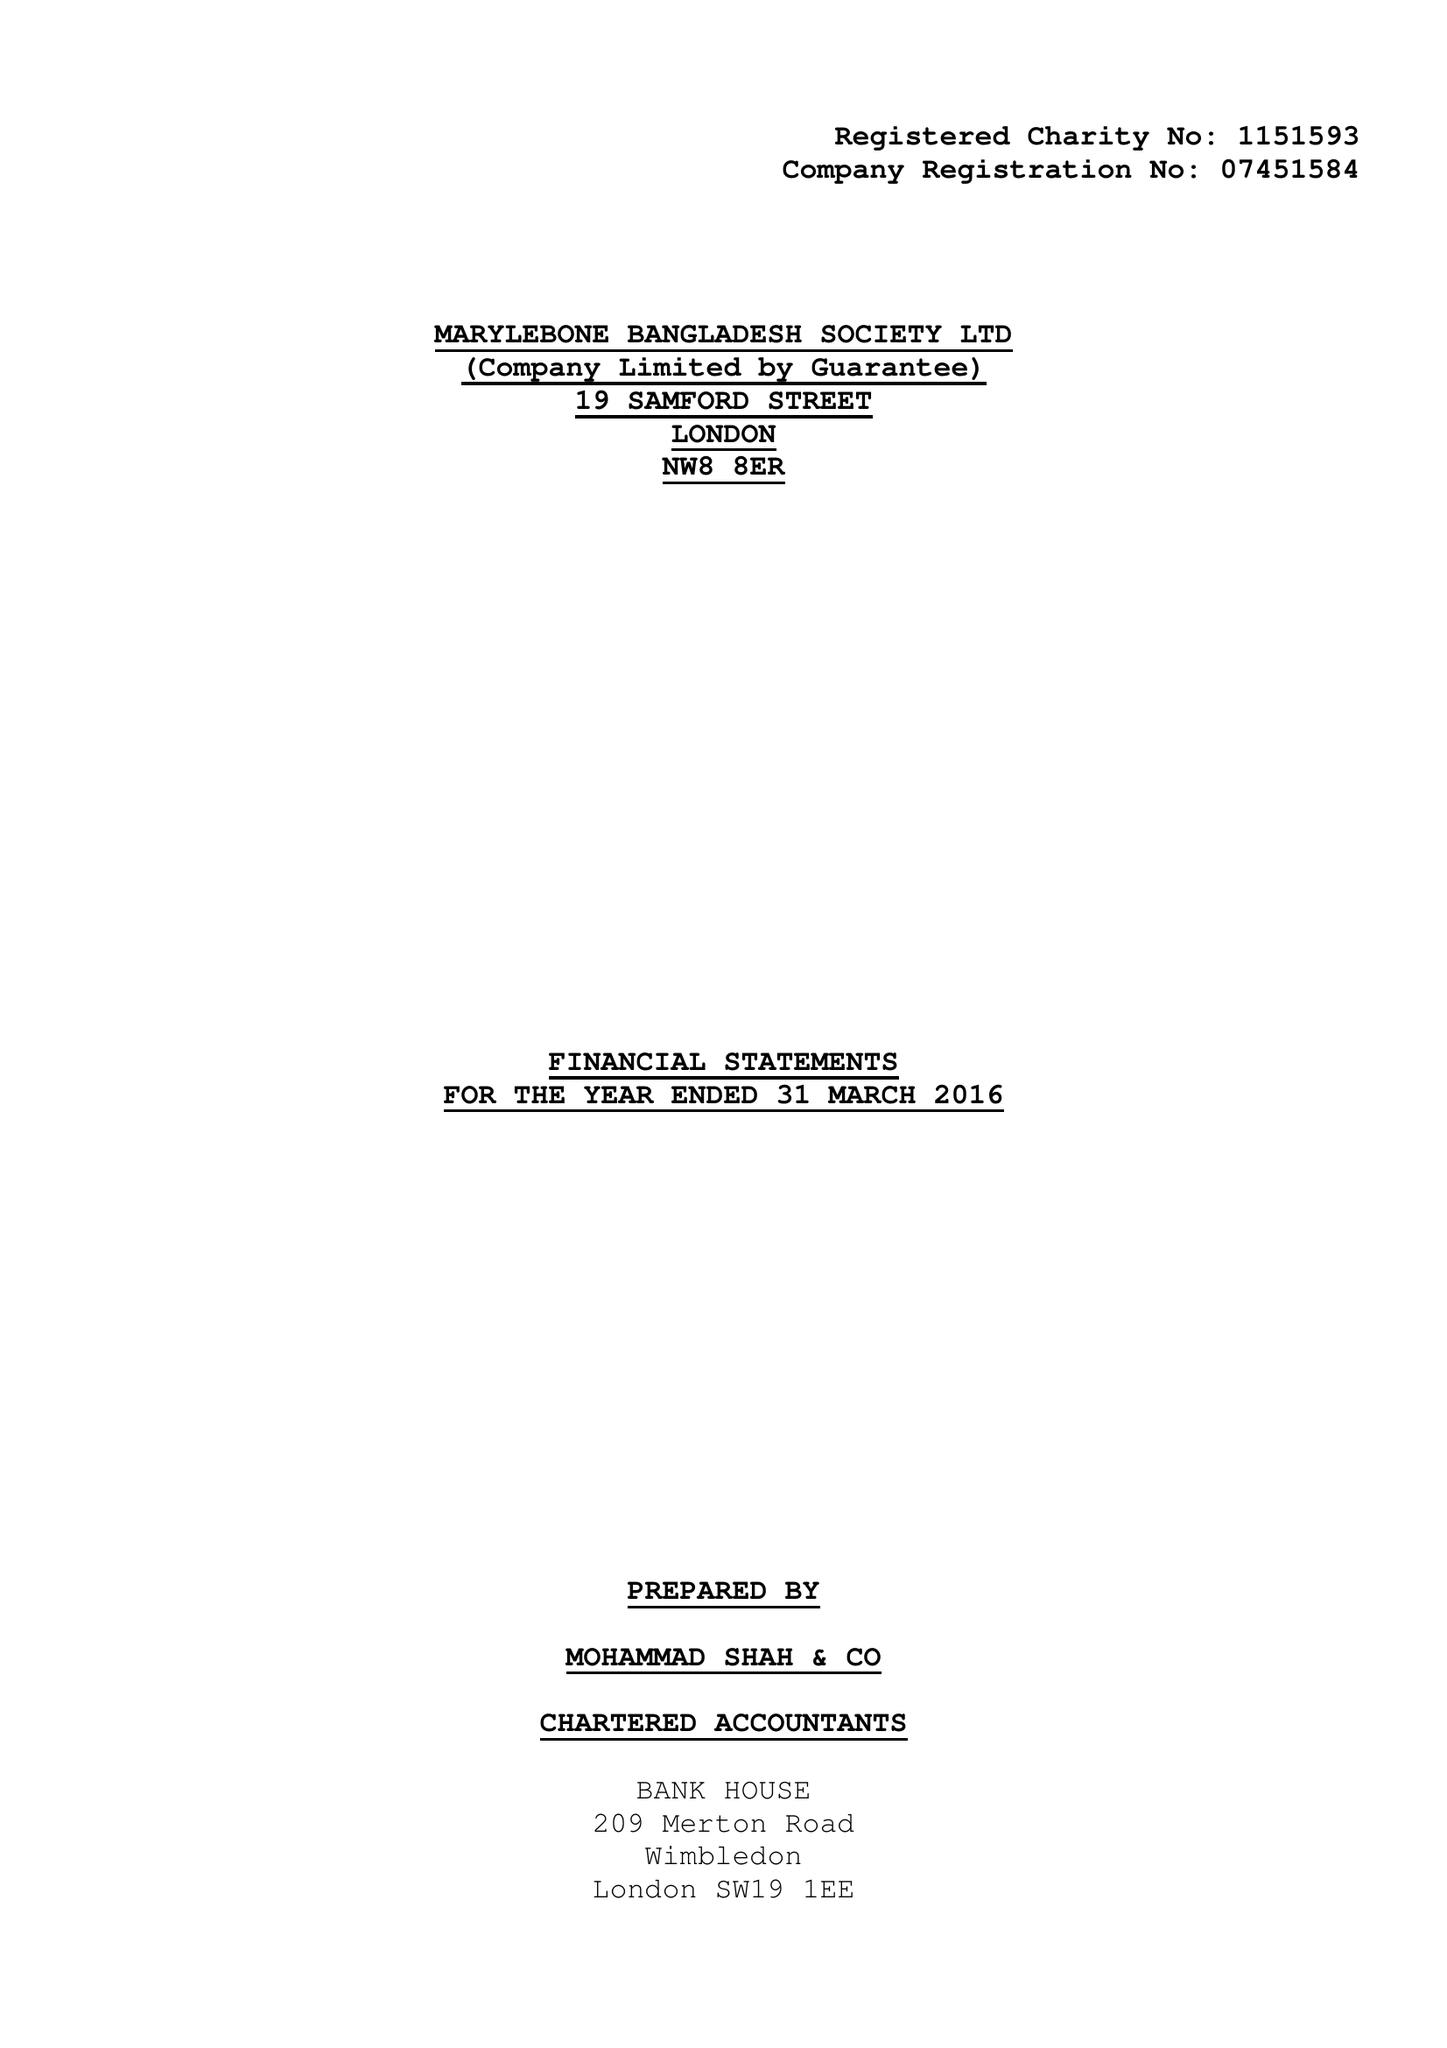What is the value for the address__street_line?
Answer the question using a single word or phrase. 19 SAMFORD STREET 